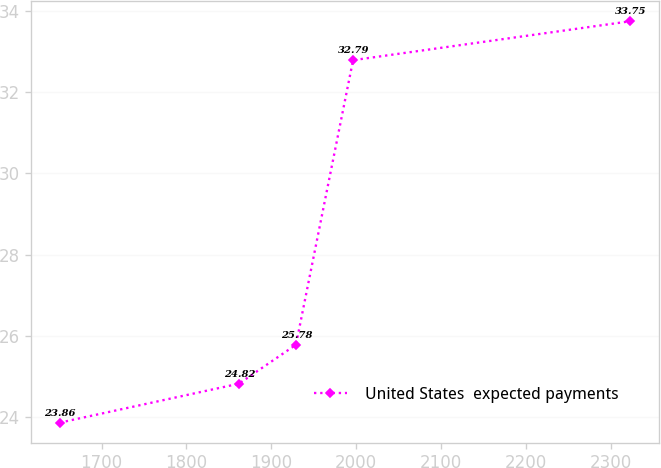<chart> <loc_0><loc_0><loc_500><loc_500><line_chart><ecel><fcel>United States  expected payments<nl><fcel>1650.66<fcel>23.86<nl><fcel>1861.82<fcel>24.82<nl><fcel>1929.06<fcel>25.78<nl><fcel>1996.3<fcel>32.79<nl><fcel>2323.09<fcel>33.75<nl></chart> 